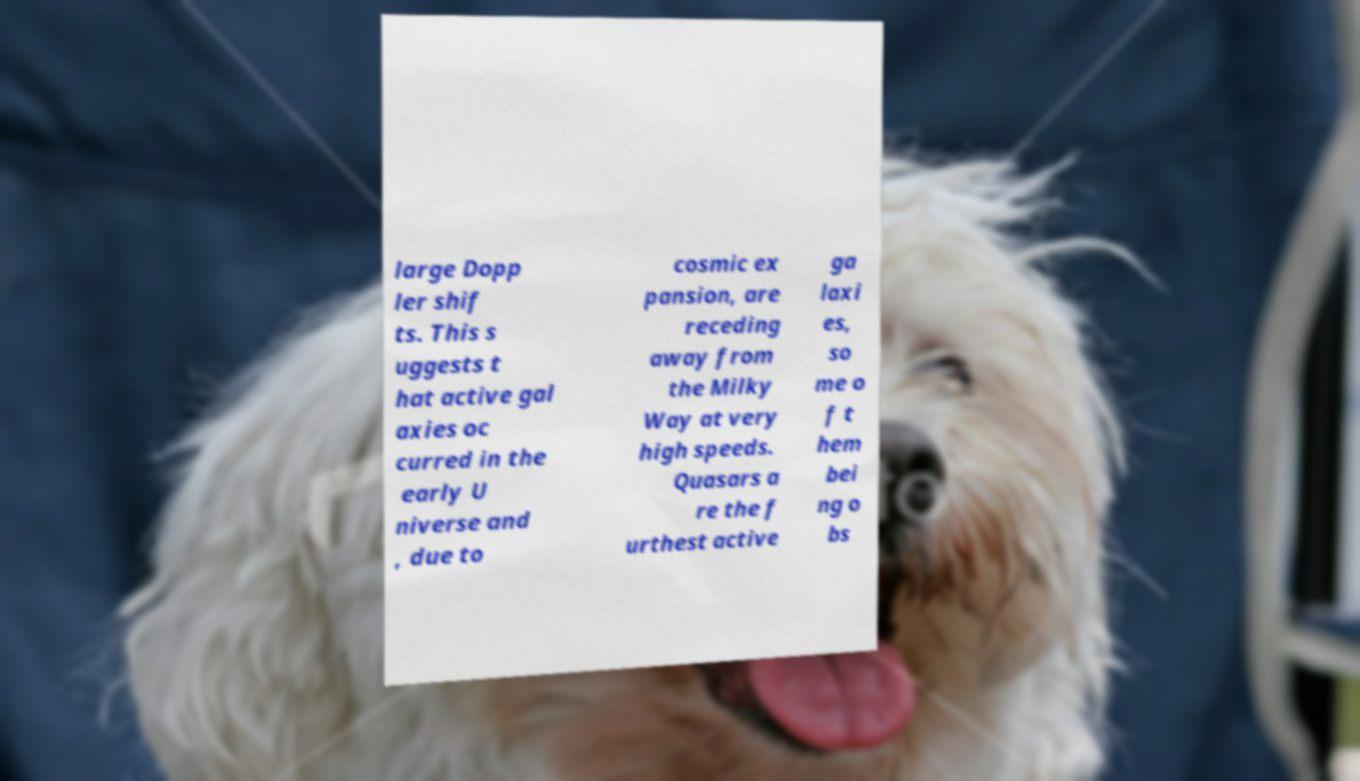Could you assist in decoding the text presented in this image and type it out clearly? large Dopp ler shif ts. This s uggests t hat active gal axies oc curred in the early U niverse and , due to cosmic ex pansion, are receding away from the Milky Way at very high speeds. Quasars a re the f urthest active ga laxi es, so me o f t hem bei ng o bs 